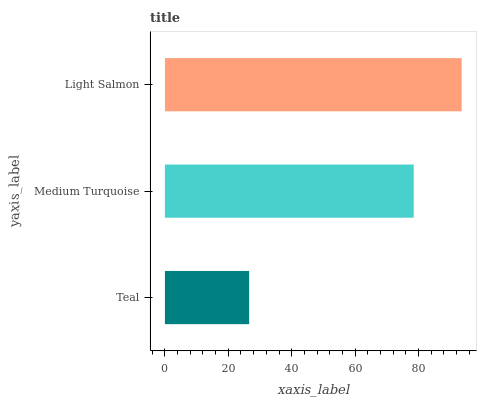Is Teal the minimum?
Answer yes or no. Yes. Is Light Salmon the maximum?
Answer yes or no. Yes. Is Medium Turquoise the minimum?
Answer yes or no. No. Is Medium Turquoise the maximum?
Answer yes or no. No. Is Medium Turquoise greater than Teal?
Answer yes or no. Yes. Is Teal less than Medium Turquoise?
Answer yes or no. Yes. Is Teal greater than Medium Turquoise?
Answer yes or no. No. Is Medium Turquoise less than Teal?
Answer yes or no. No. Is Medium Turquoise the high median?
Answer yes or no. Yes. Is Medium Turquoise the low median?
Answer yes or no. Yes. Is Teal the high median?
Answer yes or no. No. Is Light Salmon the low median?
Answer yes or no. No. 